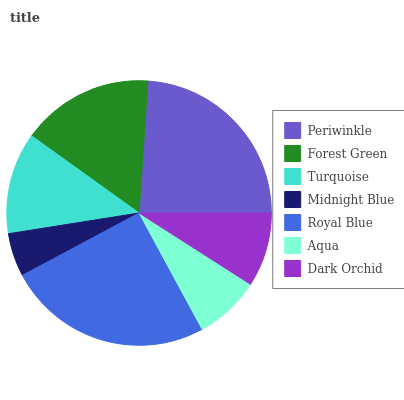Is Midnight Blue the minimum?
Answer yes or no. Yes. Is Royal Blue the maximum?
Answer yes or no. Yes. Is Forest Green the minimum?
Answer yes or no. No. Is Forest Green the maximum?
Answer yes or no. No. Is Periwinkle greater than Forest Green?
Answer yes or no. Yes. Is Forest Green less than Periwinkle?
Answer yes or no. Yes. Is Forest Green greater than Periwinkle?
Answer yes or no. No. Is Periwinkle less than Forest Green?
Answer yes or no. No. Is Turquoise the high median?
Answer yes or no. Yes. Is Turquoise the low median?
Answer yes or no. Yes. Is Forest Green the high median?
Answer yes or no. No. Is Forest Green the low median?
Answer yes or no. No. 